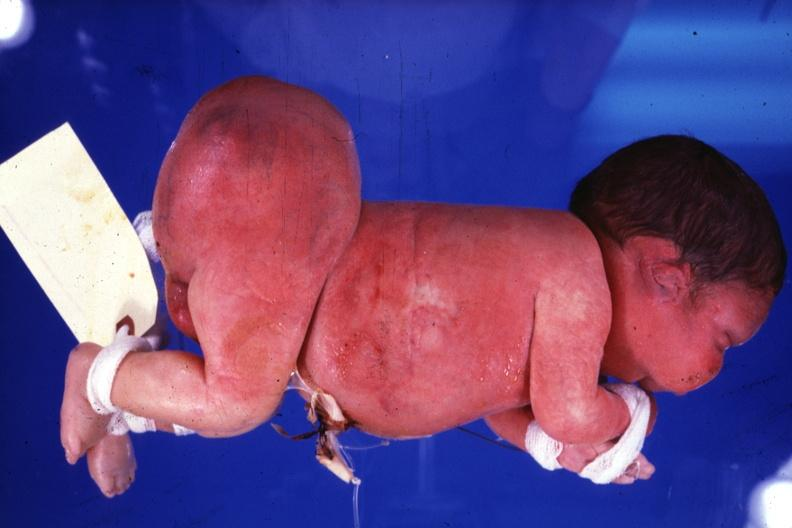what is present?
Answer the question using a single word or phrase. Sacrococcygeal teratoma 